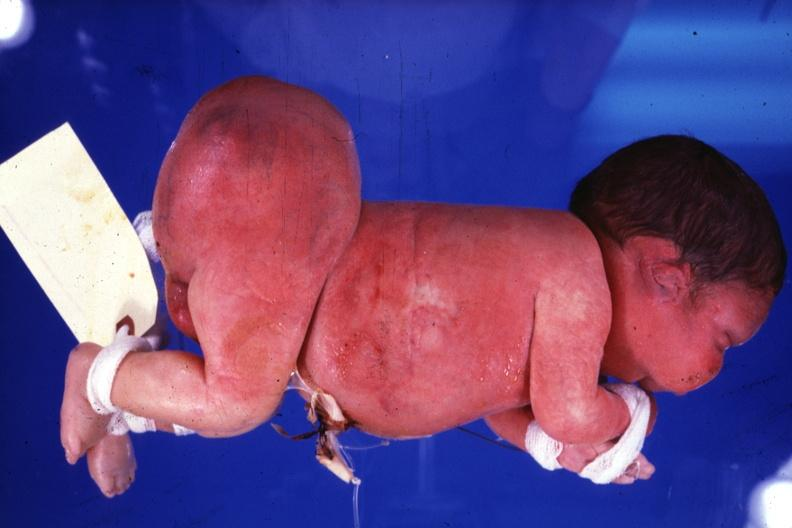what is present?
Answer the question using a single word or phrase. Sacrococcygeal teratoma 